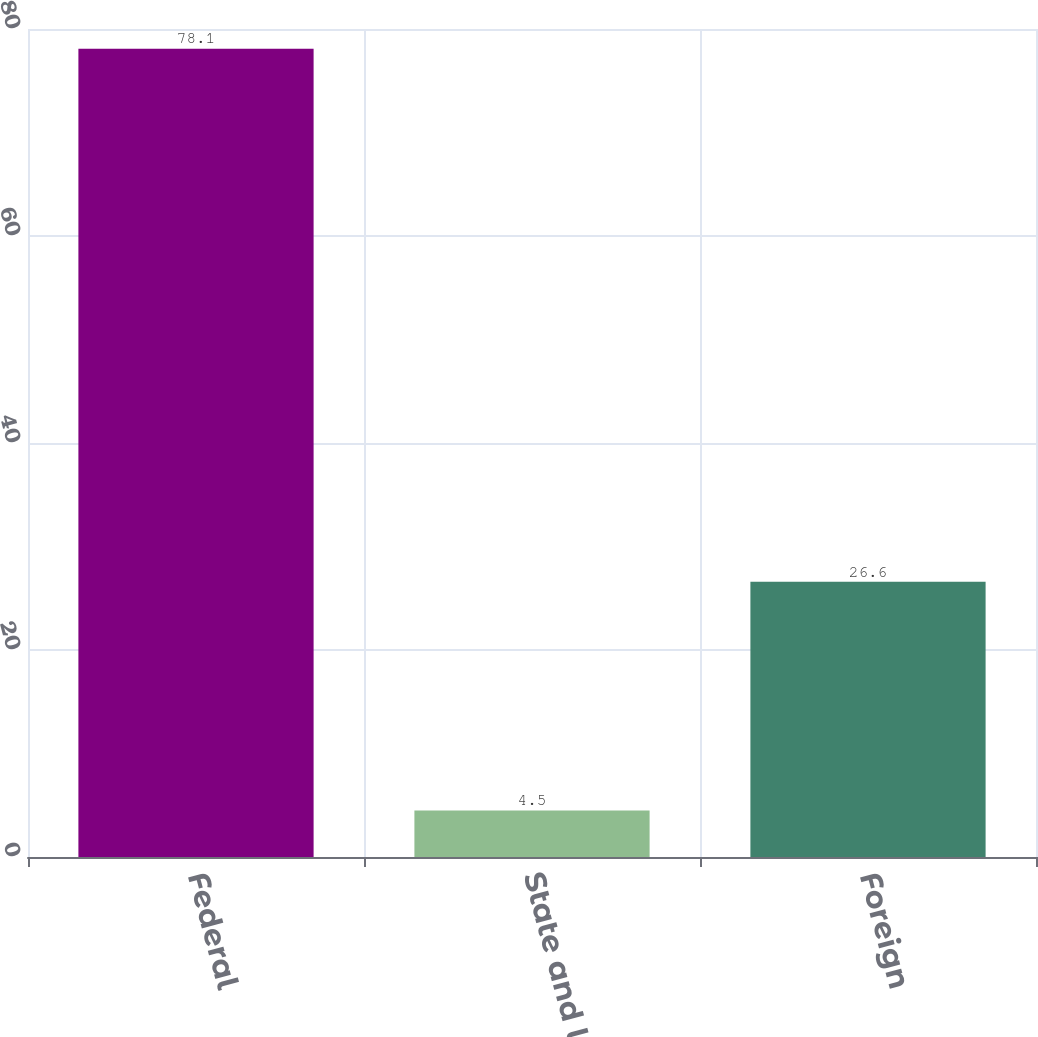<chart> <loc_0><loc_0><loc_500><loc_500><bar_chart><fcel>Federal<fcel>State and local<fcel>Foreign<nl><fcel>78.1<fcel>4.5<fcel>26.6<nl></chart> 